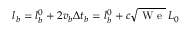<formula> <loc_0><loc_0><loc_500><loc_500>l _ { b } = l _ { b } ^ { 0 } + 2 v _ { b } \Delta t _ { b } = l _ { b } ^ { 0 } + c \sqrt { W e } \, L _ { 0 }</formula> 